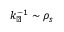<formula> <loc_0><loc_0><loc_500><loc_500>k _ { \perp } ^ { - 1 } \sim \rho _ { s }</formula> 